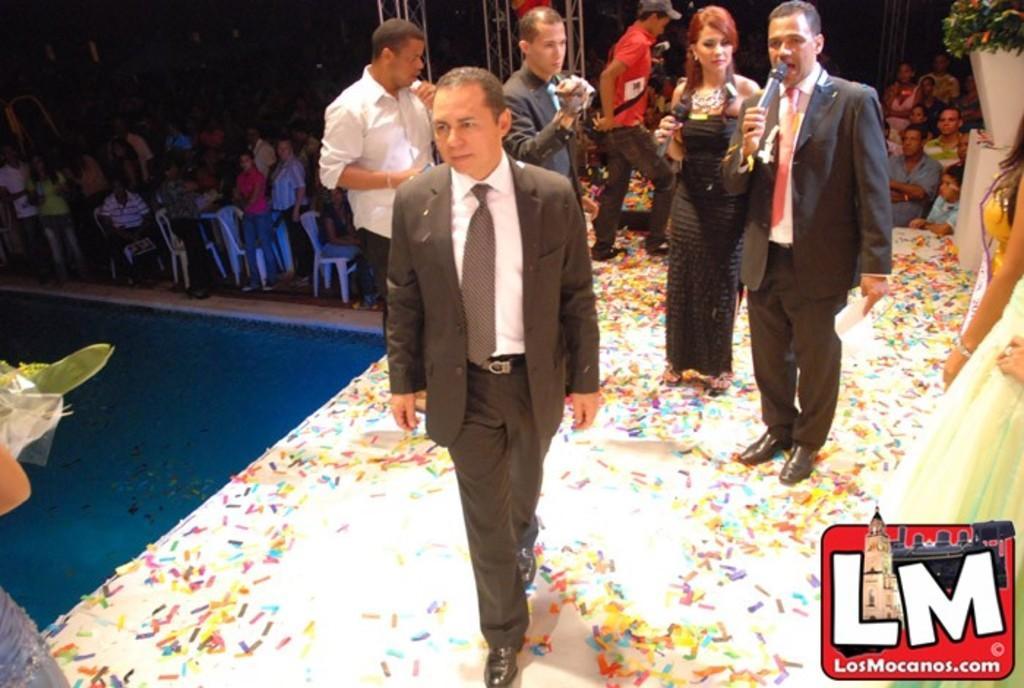How would you summarize this image in a sentence or two? In the picture I can see group of persons standing where two among them are holding a mic in their hands and there are few persons and chairs in the background. 